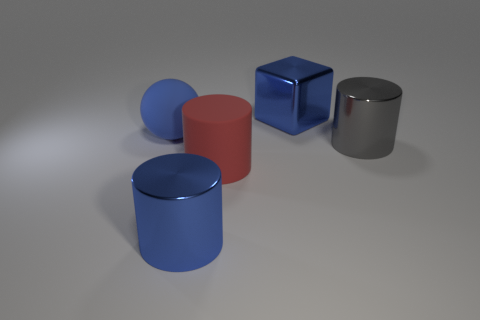What shape is the rubber object that is in front of the big matte ball?
Provide a short and direct response. Cylinder. What number of objects are cyan blocks or objects in front of the large blue rubber object?
Your answer should be very brief. 3. Are the large block and the red object made of the same material?
Your response must be concise. No. Are there the same number of large blue metal cylinders behind the red matte cylinder and large blue spheres that are right of the blue sphere?
Offer a very short reply. Yes. There is a big gray cylinder; what number of gray metal cylinders are behind it?
Offer a terse response. 0. How many objects are tiny red rubber objects or big things?
Your answer should be very brief. 5. What number of matte balls have the same size as the red cylinder?
Your answer should be very brief. 1. There is a large thing on the left side of the large blue shiny thing that is in front of the gray metal cylinder; what is its shape?
Your response must be concise. Sphere. Are there fewer big metallic cylinders than objects?
Offer a very short reply. Yes. What is the color of the metal cylinder in front of the large red cylinder?
Your answer should be very brief. Blue. 